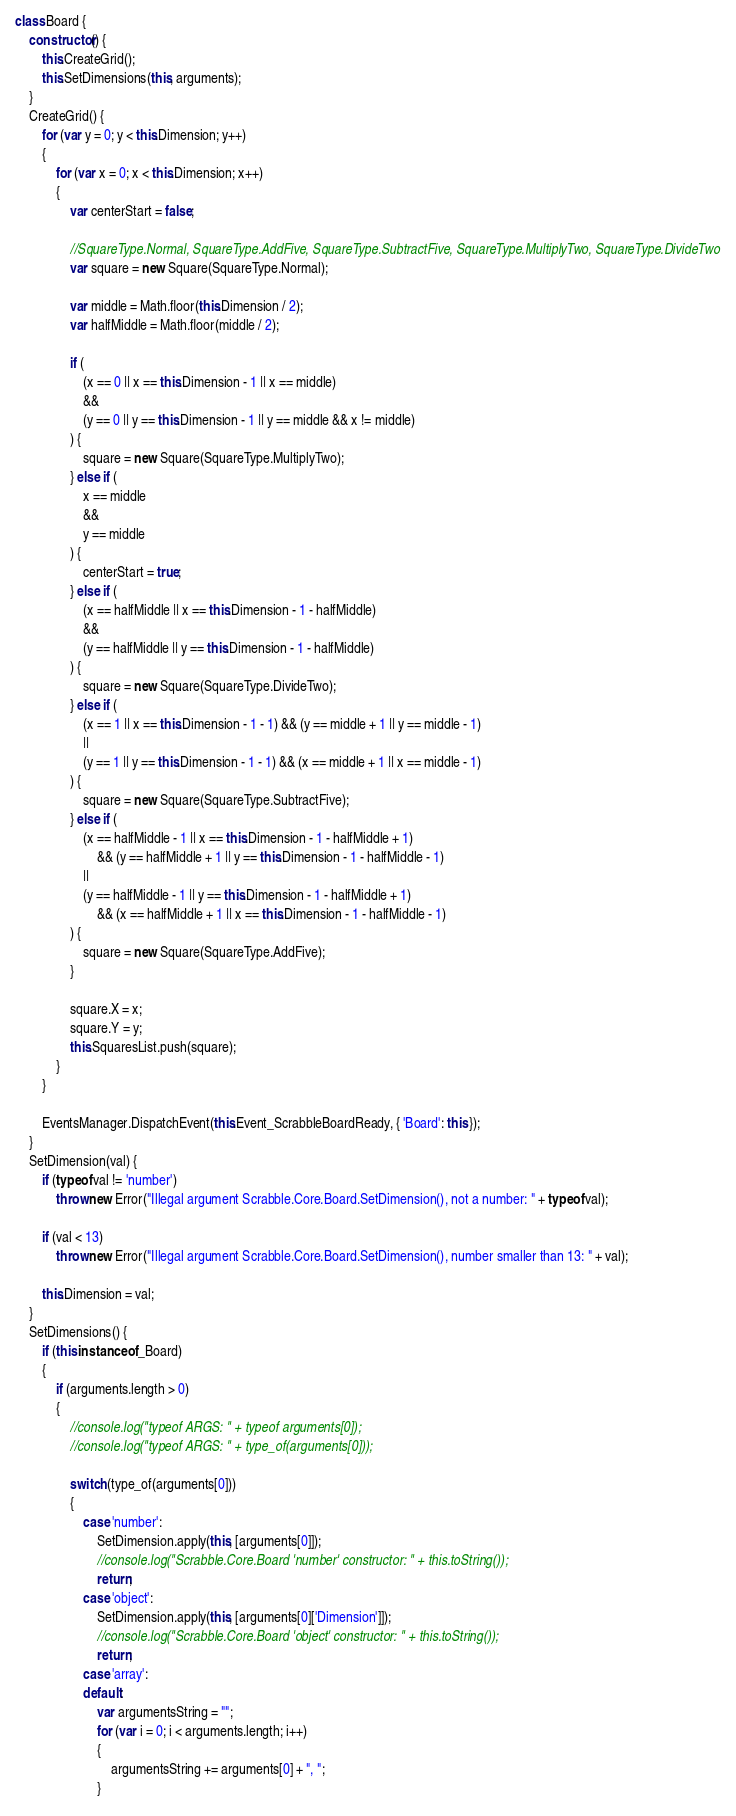<code> <loc_0><loc_0><loc_500><loc_500><_JavaScript_>class Board {
    constructor() {
        this.CreateGrid();
        this.SetDimensions(this, arguments);
    }
    CreateGrid() {
        for (var y = 0; y < this.Dimension; y++)
        {
            for (var x = 0; x < this.Dimension; x++)
            {
                var centerStart = false;

                //SquareType.Normal, SquareType.AddFive, SquareType.SubtractFive, SquareType.MultiplyTwo, SquareType.DivideTwo
                var square = new Square(SquareType.Normal);
                
                var middle = Math.floor(this.Dimension / 2);
                var halfMiddle = Math.floor(middle / 2);
                
                if (
                    (x == 0 || x == this.Dimension - 1 || x == middle)
                    &&
                    (y == 0 || y == this.Dimension - 1 || y == middle && x != middle)
                ) {
                    square = new Square(SquareType.MultiplyTwo);
                } else if (
                    x == middle
                    &&
                    y == middle
                ) {
                    centerStart = true;
                } else if (
                    (x == halfMiddle || x == this.Dimension - 1 - halfMiddle)
                    &&
                    (y == halfMiddle || y == this.Dimension - 1 - halfMiddle)
                ) {
                    square = new Square(SquareType.DivideTwo);
                } else if (
                    (x == 1 || x == this.Dimension - 1 - 1) && (y == middle + 1 || y == middle - 1)
                    ||
                    (y == 1 || y == this.Dimension - 1 - 1) && (x == middle + 1 || x == middle - 1)
                ) {
                    square = new Square(SquareType.SubtractFive);
                } else if (
                    (x == halfMiddle - 1 || x == this.Dimension - 1 - halfMiddle + 1)
                        && (y == halfMiddle + 1 || y == this.Dimension - 1 - halfMiddle - 1)
                    ||
                    (y == halfMiddle - 1 || y == this.Dimension - 1 - halfMiddle + 1)
                        && (x == halfMiddle + 1 || x == this.Dimension - 1 - halfMiddle - 1)
                ) {
                    square = new Square(SquareType.AddFive);
                }
                
                square.X = x;
                square.Y = y;
                this.SquaresList.push(square);
            }
        }
        
        EventsManager.DispatchEvent(this.Event_ScrabbleBoardReady, { 'Board': this });
    }
    SetDimension(val) {
        if (typeof val != 'number')
            throw new Error("Illegal argument Scrabble.Core.Board.SetDimension(), not a number: " + typeof val);
        
        if (val < 13)
            throw new Error("Illegal argument Scrabble.Core.Board.SetDimension(), number smaller than 13: " + val);
        
        this.Dimension = val;
    }
    SetDimensions() {
        if (this instanceof _Board)
        {
            if (arguments.length > 0)
            {
                //console.log("typeof ARGS: " + typeof arguments[0]);
                //console.log("typeof ARGS: " + type_of(arguments[0]));
            
                switch (type_of(arguments[0]))
                {
                    case 'number':
                        SetDimension.apply(this, [arguments[0]]);
                        //console.log("Scrabble.Core.Board 'number' constructor: " + this.toString());
                        return;
                    case 'object':
                        SetDimension.apply(this, [arguments[0]['Dimension']]);
                        //console.log("Scrabble.Core.Board 'object' constructor: " + this.toString());
                        return;
                    case 'array':
                    default:
                        var argumentsString = "";
                        for (var i = 0; i < arguments.length; i++)
                        {
                            argumentsString += arguments[0] + ", ";
                        }</code> 